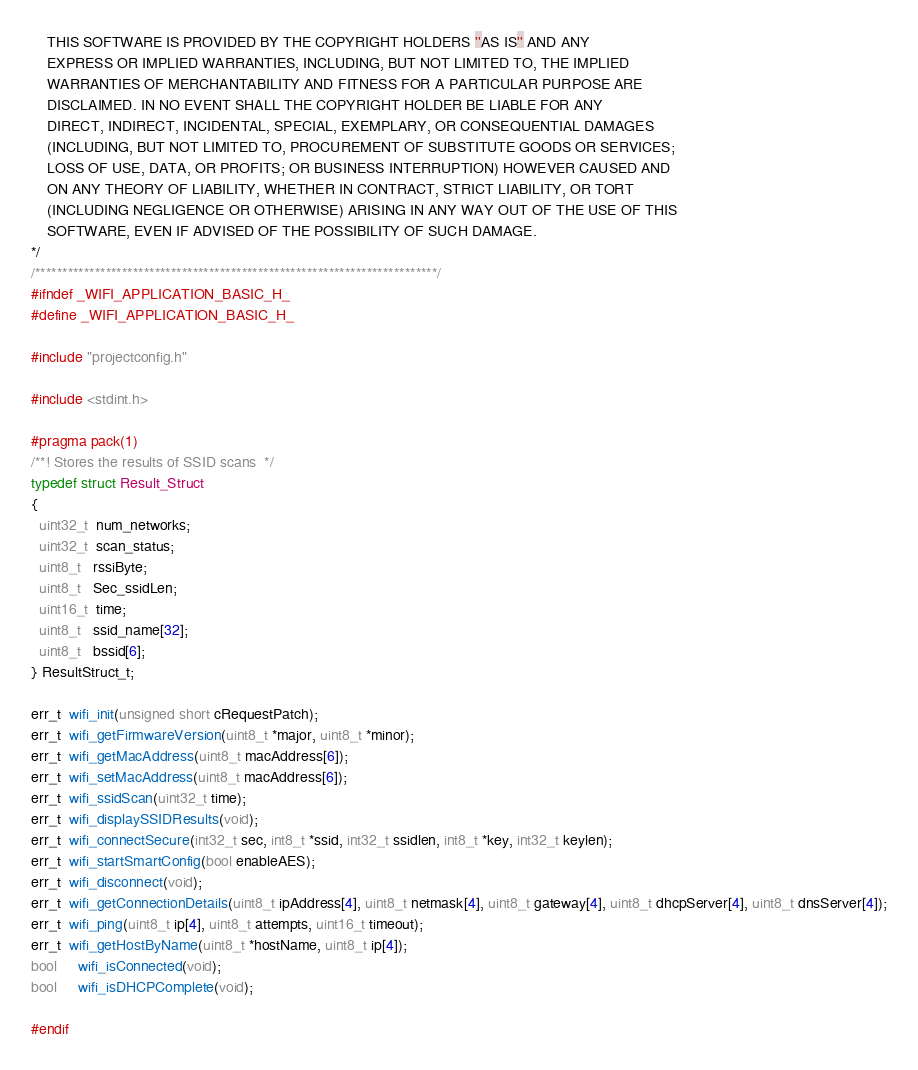Convert code to text. <code><loc_0><loc_0><loc_500><loc_500><_C_>
    THIS SOFTWARE IS PROVIDED BY THE COPYRIGHT HOLDERS ''AS IS'' AND ANY
    EXPRESS OR IMPLIED WARRANTIES, INCLUDING, BUT NOT LIMITED TO, THE IMPLIED
    WARRANTIES OF MERCHANTABILITY AND FITNESS FOR A PARTICULAR PURPOSE ARE
    DISCLAIMED. IN NO EVENT SHALL THE COPYRIGHT HOLDER BE LIABLE FOR ANY
    DIRECT, INDIRECT, INCIDENTAL, SPECIAL, EXEMPLARY, OR CONSEQUENTIAL DAMAGES
    (INCLUDING, BUT NOT LIMITED TO, PROCUREMENT OF SUBSTITUTE GOODS OR SERVICES;
    LOSS OF USE, DATA, OR PROFITS; OR BUSINESS INTERRUPTION) HOWEVER CAUSED AND
    ON ANY THEORY OF LIABILITY, WHETHER IN CONTRACT, STRICT LIABILITY, OR TORT
    (INCLUDING NEGLIGENCE OR OTHERWISE) ARISING IN ANY WAY OUT OF THE USE OF THIS
    SOFTWARE, EVEN IF ADVISED OF THE POSSIBILITY OF SUCH DAMAGE.
*/
/**************************************************************************/
#ifndef _WIFI_APPLICATION_BASIC_H_
#define _WIFI_APPLICATION_BASIC_H_

#include "projectconfig.h"

#include <stdint.h>

#pragma pack(1)
/**! Stores the results of SSID scans  */
typedef struct Result_Struct
{
  uint32_t  num_networks;
  uint32_t  scan_status;
  uint8_t   rssiByte;
  uint8_t   Sec_ssidLen;
  uint16_t  time;
  uint8_t   ssid_name[32];
  uint8_t   bssid[6];
} ResultStruct_t;

err_t  wifi_init(unsigned short cRequestPatch);
err_t  wifi_getFirmwareVersion(uint8_t *major, uint8_t *minor);
err_t  wifi_getMacAddress(uint8_t macAddress[6]);
err_t  wifi_setMacAddress(uint8_t macAddress[6]);
err_t  wifi_ssidScan(uint32_t time);
err_t  wifi_displaySSIDResults(void);
err_t  wifi_connectSecure(int32_t sec, int8_t *ssid, int32_t ssidlen, int8_t *key, int32_t keylen);
err_t  wifi_startSmartConfig(bool enableAES);
err_t  wifi_disconnect(void);
err_t  wifi_getConnectionDetails(uint8_t ipAddress[4], uint8_t netmask[4], uint8_t gateway[4], uint8_t dhcpServer[4], uint8_t dnsServer[4]);
err_t  wifi_ping(uint8_t ip[4], uint8_t attempts, uint16_t timeout);
err_t  wifi_getHostByName(uint8_t *hostName, uint8_t ip[4]);
bool     wifi_isConnected(void);
bool     wifi_isDHCPComplete(void);

#endif
</code> 